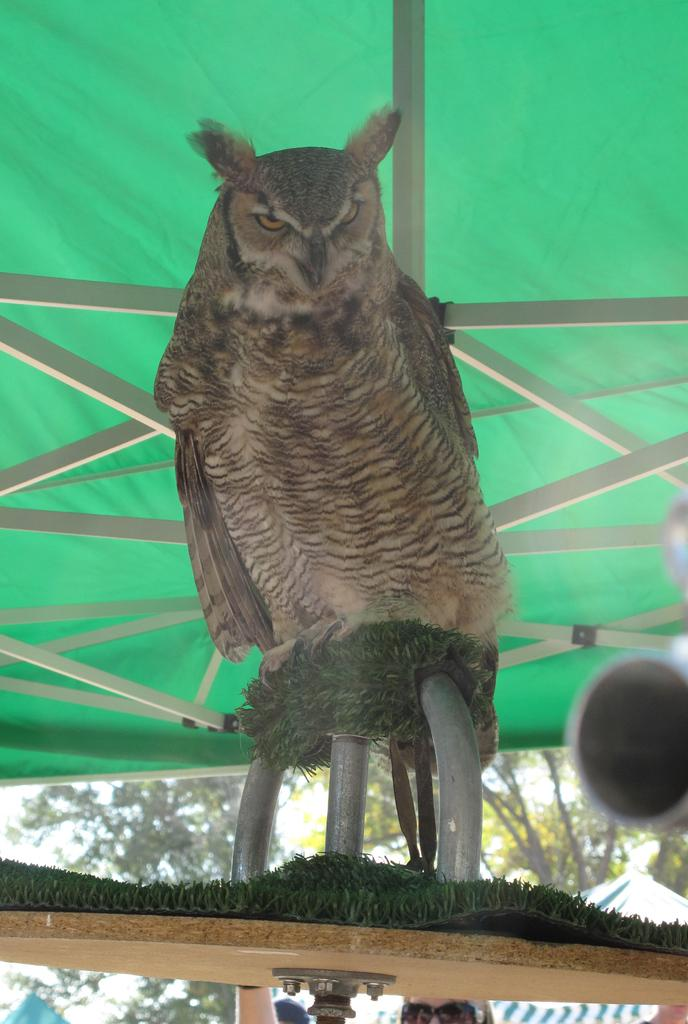What type of animal is in the image? There is an owl in the image. Where is the owl positioned in the image? The owl is sitting on a metal rod. What type of acoustics can be heard coming from the owl in the image? There is no sound or acoustics present in the image, as it is a still photograph. Can you tell me how the owl's uncle is related to the owl in the image? There is no information about the owl's uncle or any family relationships in the image. 